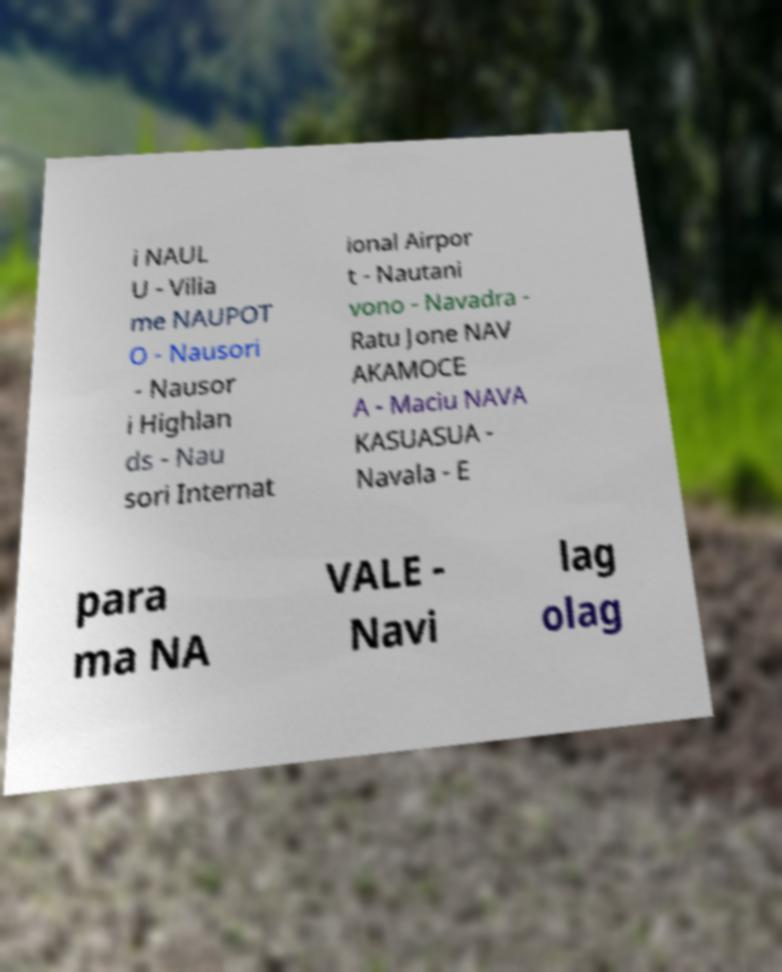For documentation purposes, I need the text within this image transcribed. Could you provide that? i NAUL U - Vilia me NAUPOT O - Nausori - Nausor i Highlan ds - Nau sori Internat ional Airpor t - Nautani vono - Navadra - Ratu Jone NAV AKAMOCE A - Maciu NAVA KASUASUA - Navala - E para ma NA VALE - Navi lag olag 